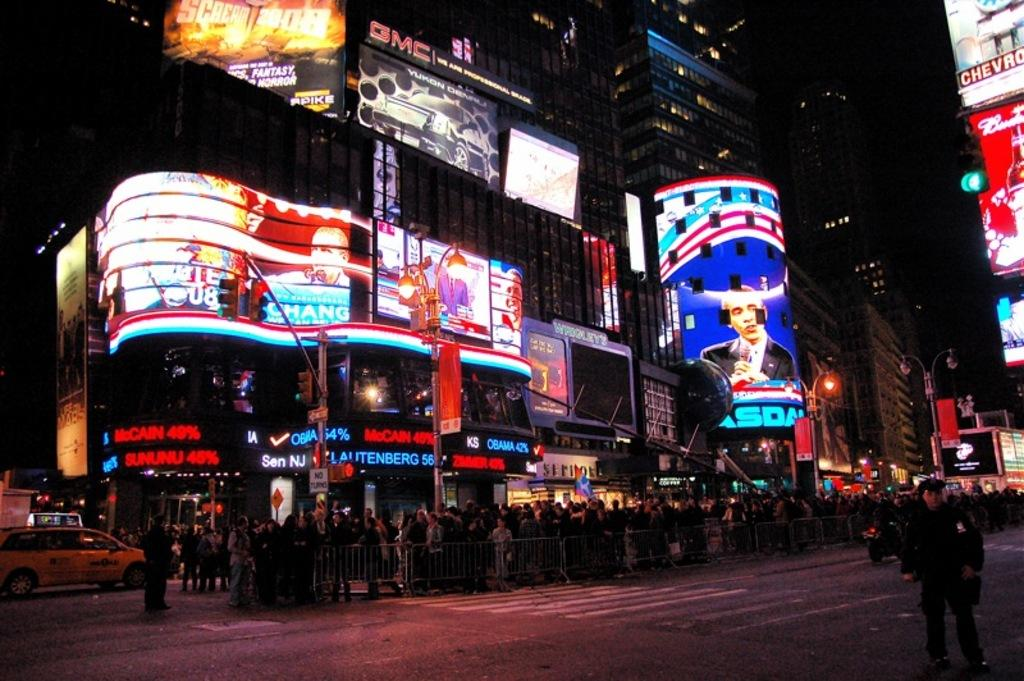<image>
Give a short and clear explanation of the subsequent image. GMC is written above on of he big signs on the left. 